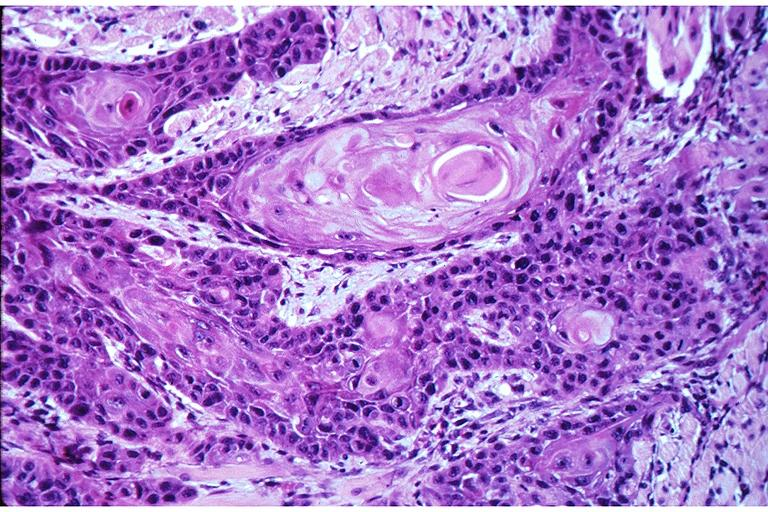what is present?
Answer the question using a single word or phrase. Oral 